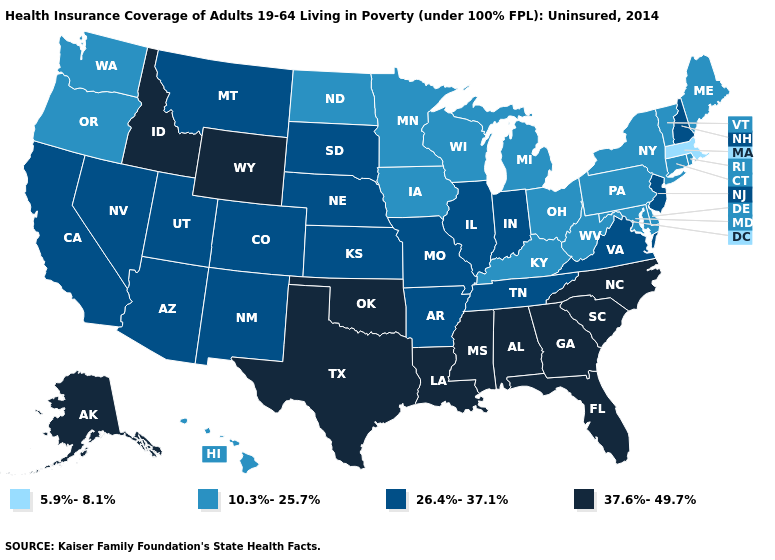What is the value of Texas?
Quick response, please. 37.6%-49.7%. What is the lowest value in states that border Delaware?
Keep it brief. 10.3%-25.7%. Name the states that have a value in the range 37.6%-49.7%?
Keep it brief. Alabama, Alaska, Florida, Georgia, Idaho, Louisiana, Mississippi, North Carolina, Oklahoma, South Carolina, Texas, Wyoming. Which states have the lowest value in the Northeast?
Answer briefly. Massachusetts. Does Washington have the same value as Indiana?
Give a very brief answer. No. Name the states that have a value in the range 5.9%-8.1%?
Short answer required. Massachusetts. What is the value of Connecticut?
Write a very short answer. 10.3%-25.7%. Which states have the highest value in the USA?
Keep it brief. Alabama, Alaska, Florida, Georgia, Idaho, Louisiana, Mississippi, North Carolina, Oklahoma, South Carolina, Texas, Wyoming. What is the value of Delaware?
Be succinct. 10.3%-25.7%. Does Montana have the same value as Kansas?
Keep it brief. Yes. What is the lowest value in the USA?
Keep it brief. 5.9%-8.1%. Which states have the highest value in the USA?
Keep it brief. Alabama, Alaska, Florida, Georgia, Idaho, Louisiana, Mississippi, North Carolina, Oklahoma, South Carolina, Texas, Wyoming. Is the legend a continuous bar?
Write a very short answer. No. What is the highest value in states that border Virginia?
Short answer required. 37.6%-49.7%. 